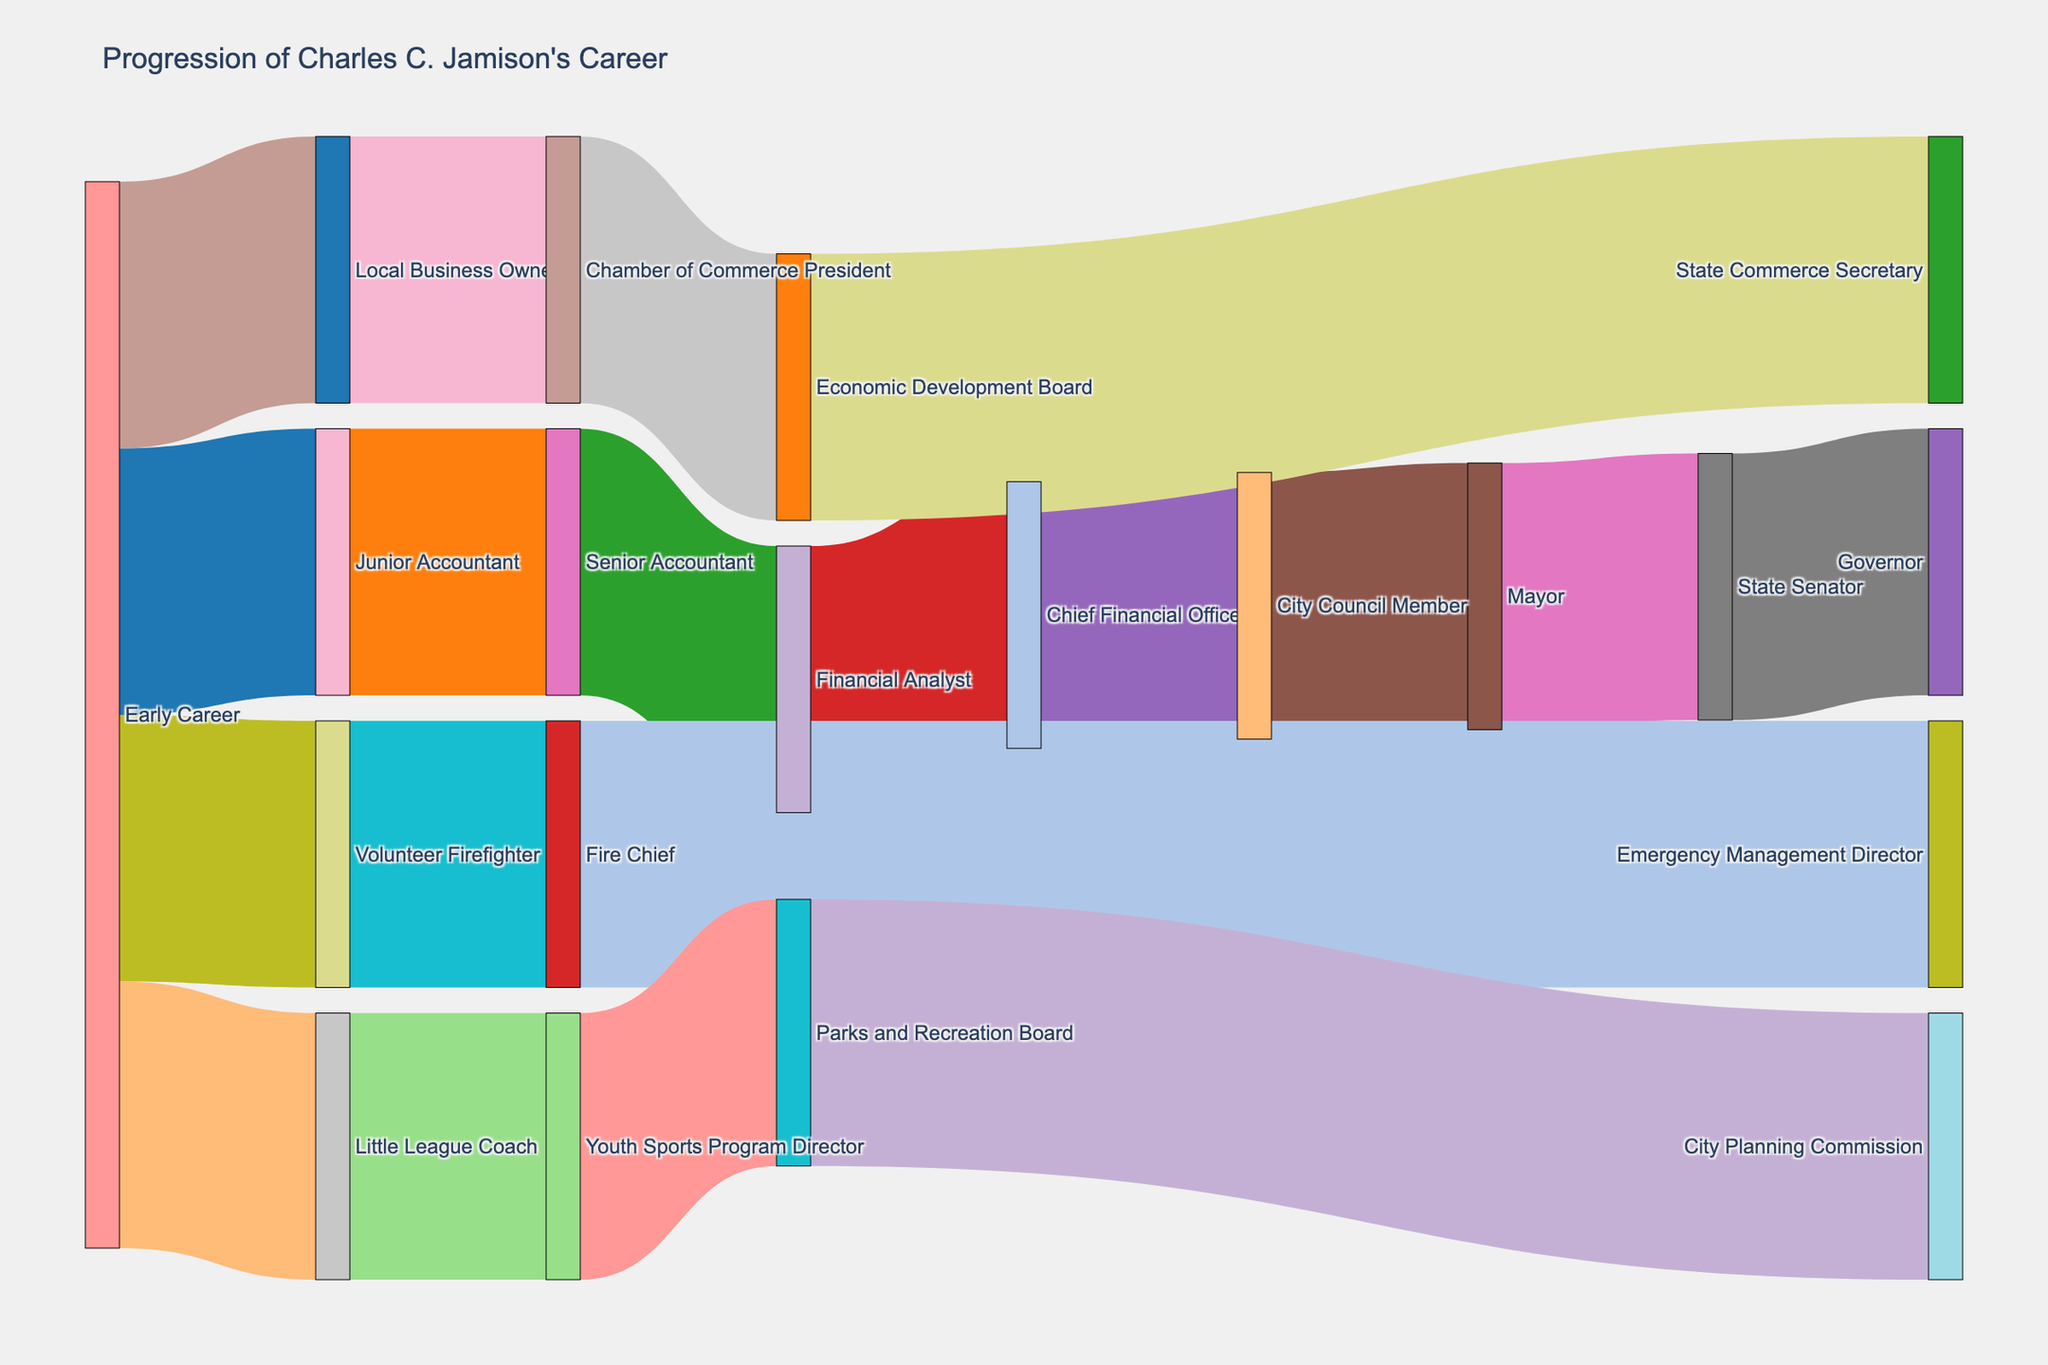How many roles did Charles C. Jamison have after his Early Career? To count the total roles after the Early Career, sum the "Value" of all nodes connected downstream from "Early Career". These are nodes directly or indirectly connected to "Early Career": Junior Accountant (1), Volunteer Firefighter (1), Little League Coach (1), and Local Business Owner (1) making a total of 4 initial roles, which further expand.
Answer: 16 Which roles did Charles C. Jamison hold in the finance field? Identify the nodes associated with financial roles and ensure they are connected through a progression path. These are Junior Accountant, Senior Accountant, Financial Analyst, and Chief Financial Officer.
Answer: 4 What was Charles C. Jamison’s role before becoming the Mayor? Follow the progression path leading to Mayor. The role preceding Mayor is City Council Member.
Answer: City Council Member How did Charles C. Jamison's role evolve in public service from the City Council Member to the Governor? Trace the public service path starting from City Council Member: City Council Member -> Mayor -> State Senator -> Governor.
Answer: Governor Which role has the most connections branching out from it directly? Examine which role has the highest number of direct outgoing connections. Early Career has connections leading to Junior Accountant, Volunteer Firefighter, Little League Coach, and Local Business Owner.
Answer: Early Career From which initial career path was Charles C. Jamison the Chamber of Commerce President? Track the path from initial to Chamber of Commerce President: Early Career -> Local Business Owner -> Chamber of Commerce President.
Answer: Local Business Owner If we follow the Volunteer Firefighter path, what is the highest position Charles reached? Follow the Volunteer Firefighter path: Volunteer Firefighter -> Fire Chief -> Emergency Management Director. The highest role is Emergency Management Director.
Answer: Emergency Management Director Which path led Charles C. Jamison to the City Planning Commission? Track the path leading to City Planning Commission: Early Career -> Little League Coach -> Youth Sports Program Director -> Parks and Recreation Board -> City Planning Commission.
Answer: City Planning Commission Did Charles C. Jamison have any roles related to economic development? Identify roles associated with economic development: Local Business Owner -> Chamber of Commerce President -> Economic Development Board -> State Commerce Secretary.
Answer: 4 